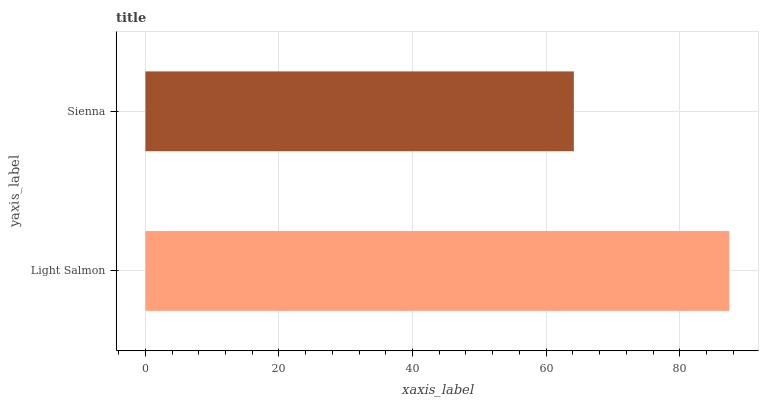Is Sienna the minimum?
Answer yes or no. Yes. Is Light Salmon the maximum?
Answer yes or no. Yes. Is Sienna the maximum?
Answer yes or no. No. Is Light Salmon greater than Sienna?
Answer yes or no. Yes. Is Sienna less than Light Salmon?
Answer yes or no. Yes. Is Sienna greater than Light Salmon?
Answer yes or no. No. Is Light Salmon less than Sienna?
Answer yes or no. No. Is Light Salmon the high median?
Answer yes or no. Yes. Is Sienna the low median?
Answer yes or no. Yes. Is Sienna the high median?
Answer yes or no. No. Is Light Salmon the low median?
Answer yes or no. No. 